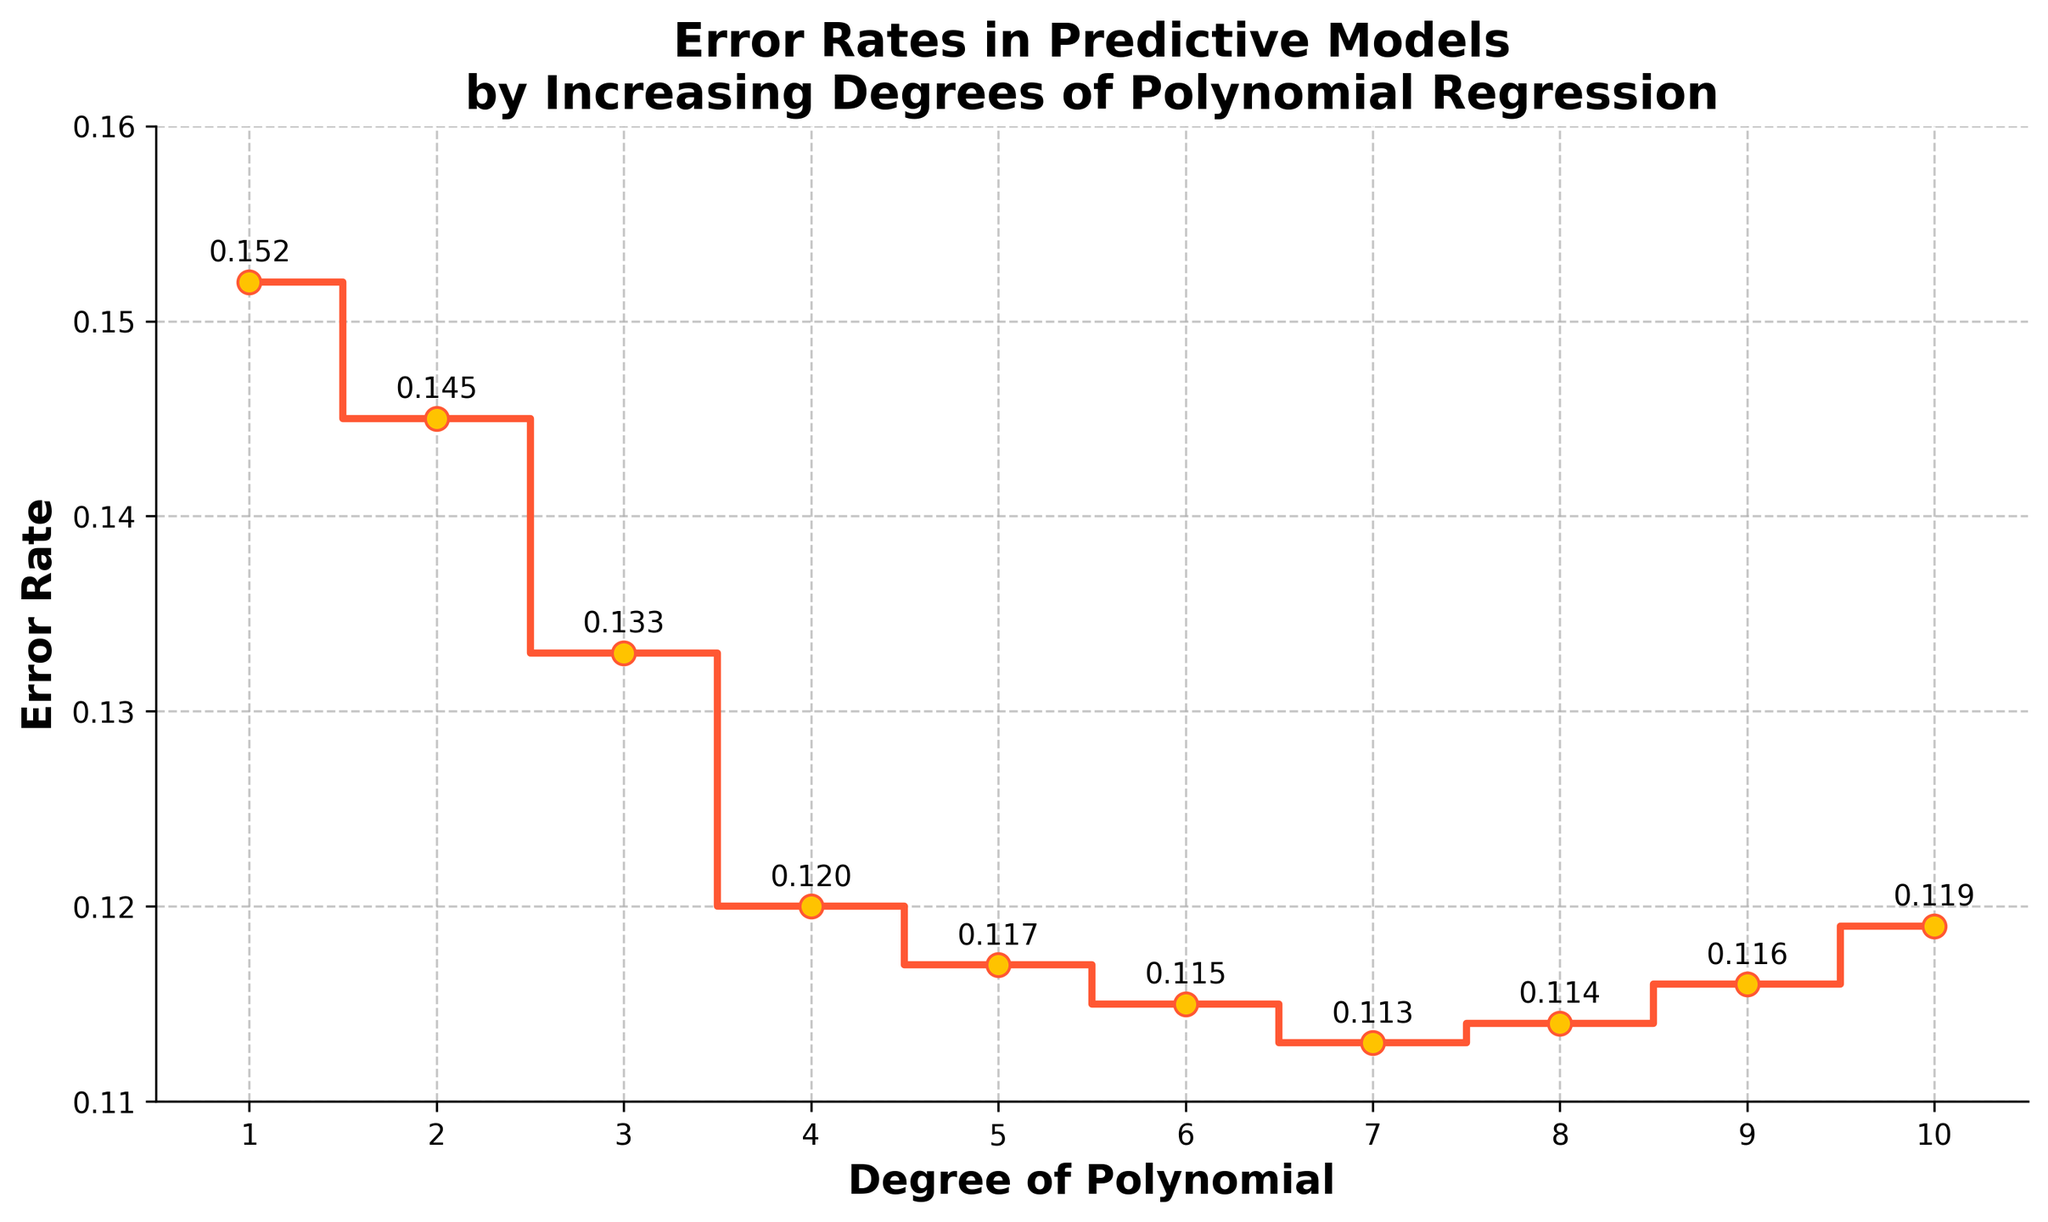How many data points are shown in the figure? Count the number of markers or data points plotted on the stair plot. There are markers for polynomial degrees from 1 to 10.
Answer: 10 What is the title of the figure? Look at the top of the figure where the title is displayed.
Answer: Error Rates in Predictive Models by Increasing Degrees of Polynomial Regression What is the range of the x-axis? Check the labels and ticks along the x-axis. The figure's x-axis ranges from 0.5 to 10.5.
Answer: 0.5 to 10.5 What is the minimum error rate plotted, and at which degree does it occur? Identify the lowest error rate value on the y-axis and the corresponding x-axis degree. The lowest error rate is 0.113 at degree 7.
Answer: 0.113 at degree 7 What is the color of the markers used in the plot? Observe the color of the markers on the plot.
Answer: Orange At which polynomial degree does the error rate start increasing again after reaching its minimum? Find the degree just after the lowest error rate where the error rate starts to rise again. The lowest error rate is at degree 7, and the error rate starts increasing again from degree 8.
Answer: 8 What is the maximum error rate plotted, and at which degree does it occur? Identify the highest error rate value on the y-axis and the corresponding x-axis degree. The highest error rate is 0.152 at degree 1.
Answer: 0.152 at degree 1 What is the average error rate across all plotted polynomial degrees? Sum all the error rates and divide by the number of data points (10). The sum of the error rates is 1.244, and the average is 1.244/10.
Answer: 0.1244 How does the error rate at degree 4 compare to that at degree 8? Compare the error rates at degrees 4 and 8. The error rate at degree 4 is 0.120, and at degree 8 it is 0.114.
Answer: Higher at degree 4 What is the total change in error rate from degree 1 to degree 7? Subtract the error rate at degree 1 from the error rate at degree 7. The error rate at degree 1 is 0.152 and at degree 7 it is 0.113. The change is 0.113 - 0.152.
Answer: -0.039 